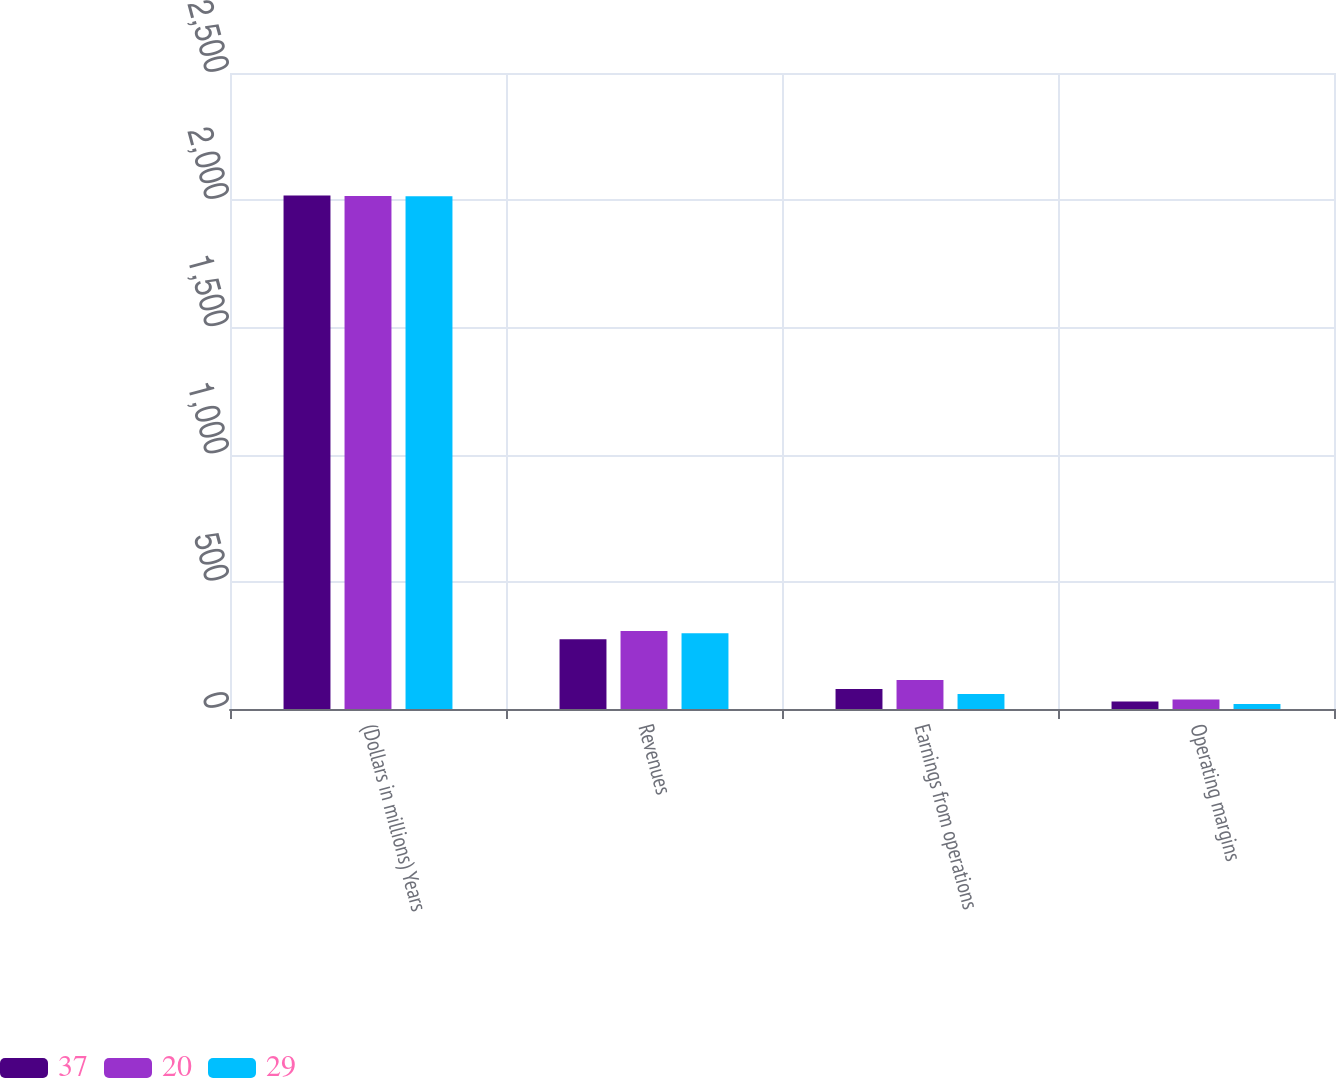Convert chart to OTSL. <chart><loc_0><loc_0><loc_500><loc_500><stacked_bar_chart><ecel><fcel>(Dollars in millions) Years<fcel>Revenues<fcel>Earnings from operations<fcel>Operating margins<nl><fcel>37<fcel>2018<fcel>274<fcel>79<fcel>29<nl><fcel>20<fcel>2017<fcel>307<fcel>114<fcel>37<nl><fcel>29<fcel>2016<fcel>298<fcel>59<fcel>20<nl></chart> 